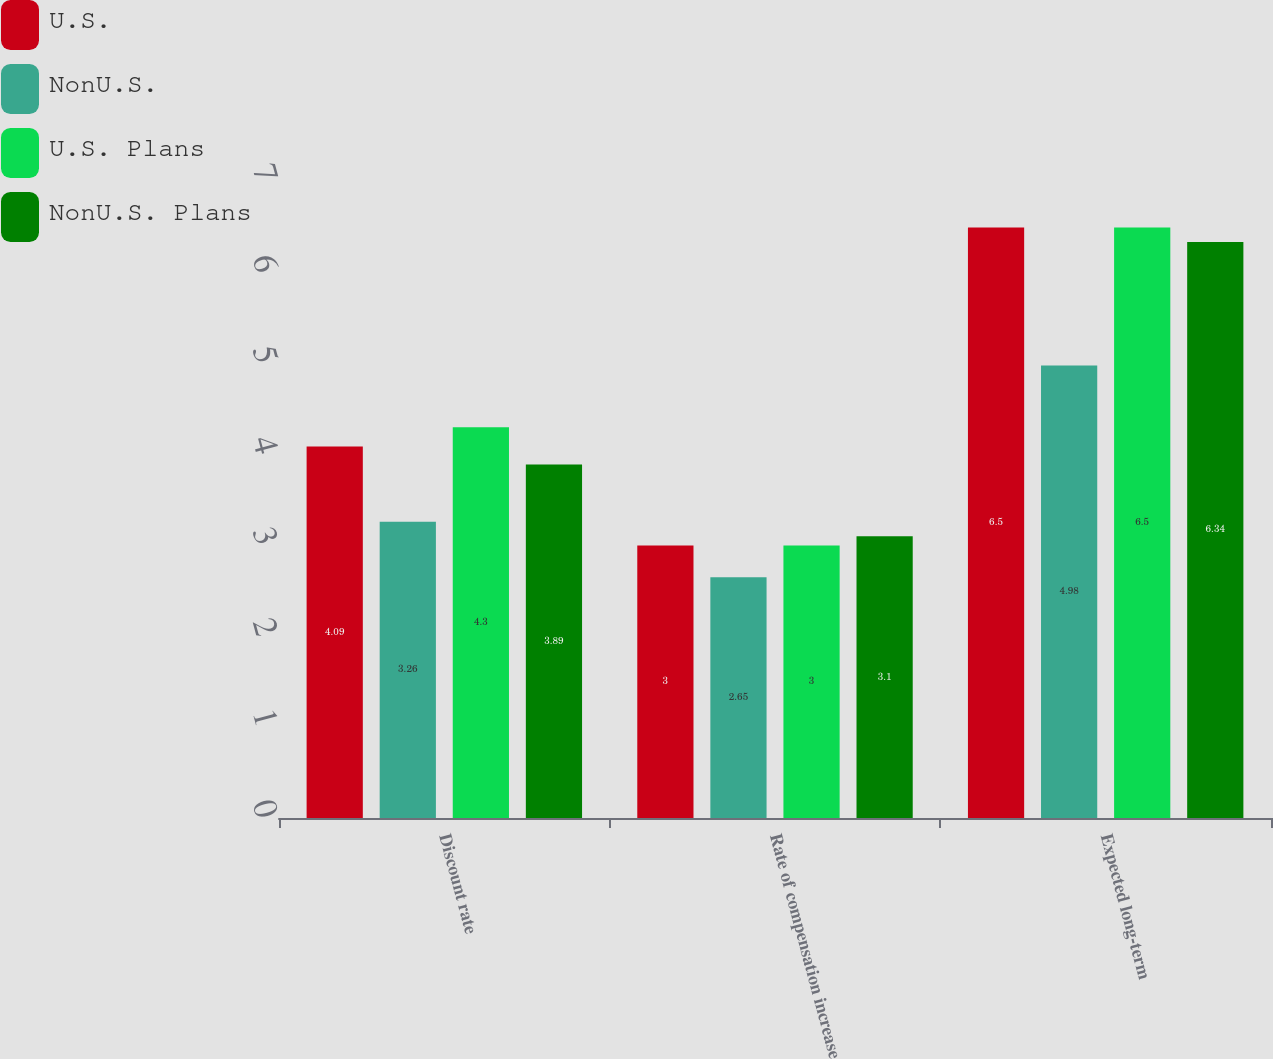<chart> <loc_0><loc_0><loc_500><loc_500><stacked_bar_chart><ecel><fcel>Discount rate<fcel>Rate of compensation increase<fcel>Expected long-term<nl><fcel>U.S.<fcel>4.09<fcel>3<fcel>6.5<nl><fcel>NonU.S.<fcel>3.26<fcel>2.65<fcel>4.98<nl><fcel>U.S. Plans<fcel>4.3<fcel>3<fcel>6.5<nl><fcel>NonU.S. Plans<fcel>3.89<fcel>3.1<fcel>6.34<nl></chart> 